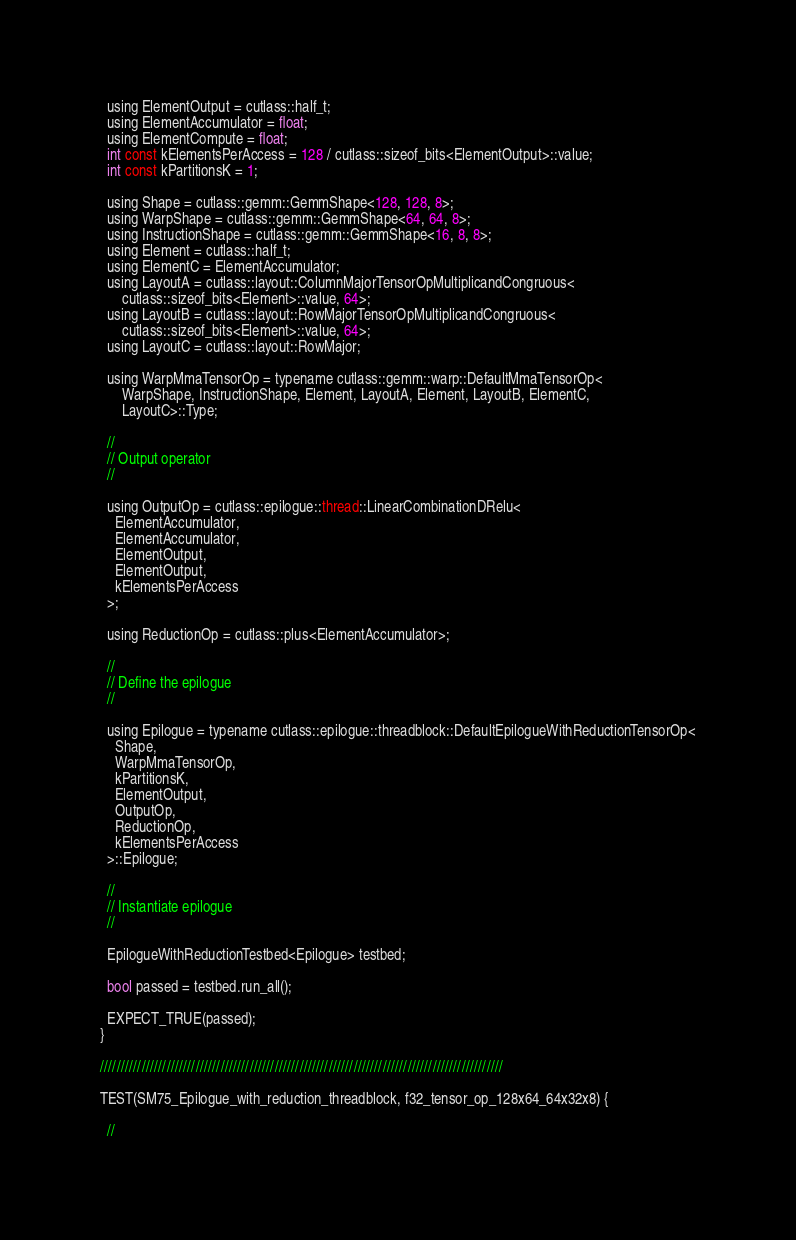Convert code to text. <code><loc_0><loc_0><loc_500><loc_500><_Cuda_>
  using ElementOutput = cutlass::half_t;
  using ElementAccumulator = float;
  using ElementCompute = float;
  int const kElementsPerAccess = 128 / cutlass::sizeof_bits<ElementOutput>::value;
  int const kPartitionsK = 1;
  
  using Shape = cutlass::gemm::GemmShape<128, 128, 8>;
  using WarpShape = cutlass::gemm::GemmShape<64, 64, 8>;
  using InstructionShape = cutlass::gemm::GemmShape<16, 8, 8>;
  using Element = cutlass::half_t;
  using ElementC = ElementAccumulator;
  using LayoutA = cutlass::layout::ColumnMajorTensorOpMultiplicandCongruous<
      cutlass::sizeof_bits<Element>::value, 64>;
  using LayoutB = cutlass::layout::RowMajorTensorOpMultiplicandCongruous<
      cutlass::sizeof_bits<Element>::value, 64>;
  using LayoutC = cutlass::layout::RowMajor;

  using WarpMmaTensorOp = typename cutlass::gemm::warp::DefaultMmaTensorOp<
      WarpShape, InstructionShape, Element, LayoutA, Element, LayoutB, ElementC,
      LayoutC>::Type;

  //
  // Output operator
  //

  using OutputOp = cutlass::epilogue::thread::LinearCombinationDRelu<
    ElementAccumulator,
    ElementAccumulator,
    ElementOutput,
    ElementOutput,
    kElementsPerAccess
  >;

  using ReductionOp = cutlass::plus<ElementAccumulator>;

  //
  // Define the epilogue
  //

  using Epilogue = typename cutlass::epilogue::threadblock::DefaultEpilogueWithReductionTensorOp<
    Shape,
    WarpMmaTensorOp,
    kPartitionsK,
    ElementOutput,
    OutputOp,
    ReductionOp,
    kElementsPerAccess
  >::Epilogue;

  //
  // Instantiate epilogue
  //

  EpilogueWithReductionTestbed<Epilogue> testbed;

  bool passed = testbed.run_all();

  EXPECT_TRUE(passed);
}

/////////////////////////////////////////////////////////////////////////////////////////////////

TEST(SM75_Epilogue_with_reduction_threadblock, f32_tensor_op_128x64_64x32x8) {

  //</code> 